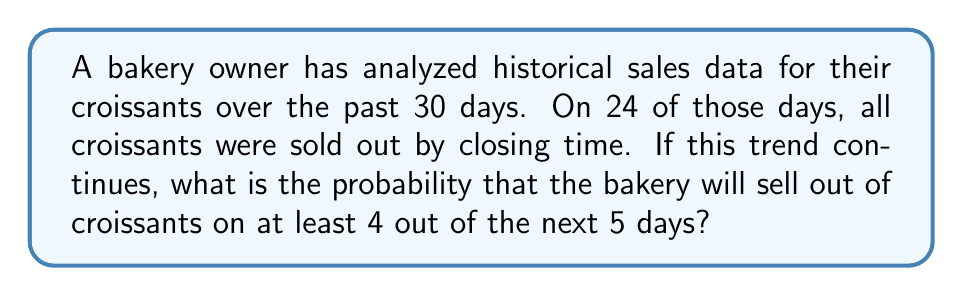Show me your answer to this math problem. Let's approach this step-by-step:

1) First, we need to calculate the probability of selling out croissants on a single day:
   $p = \frac{24}{30} = 0.8$ or 80%

2) The probability of not selling out on a single day is:
   $1 - p = 1 - 0.8 = 0.2$ or 20%

3) We want to find the probability of selling out on at least 4 out of 5 days. This is equivalent to the probability of selling out on either 4 or 5 days.

4) We can use the binomial probability formula:

   $$P(X = k) = \binom{n}{k} p^k (1-p)^{n-k}$$

   where $n$ is the number of trials, $k$ is the number of successes, $p$ is the probability of success on a single trial.

5) For 5 out of 5 days:
   $$P(X = 5) = \binom{5}{5} (0.8)^5 (0.2)^0 = 1 \cdot 0.32768 \cdot 1 = 0.32768$$

6) For 4 out of 5 days:
   $$P(X = 4) = \binom{5}{4} (0.8)^4 (0.2)^1 = 5 \cdot 0.4096 \cdot 0.2 = 0.4096$$

7) The probability of at least 4 out of 5 days is the sum of these probabilities:
   $$P(X \geq 4) = P(X = 4) + P(X = 5) = 0.4096 + 0.32768 = 0.73728$$

Therefore, the probability of selling out of croissants on at least 4 out of the next 5 days is approximately 0.73728 or 73.728%.
Answer: $0.73728$ or $73.728\%$ 